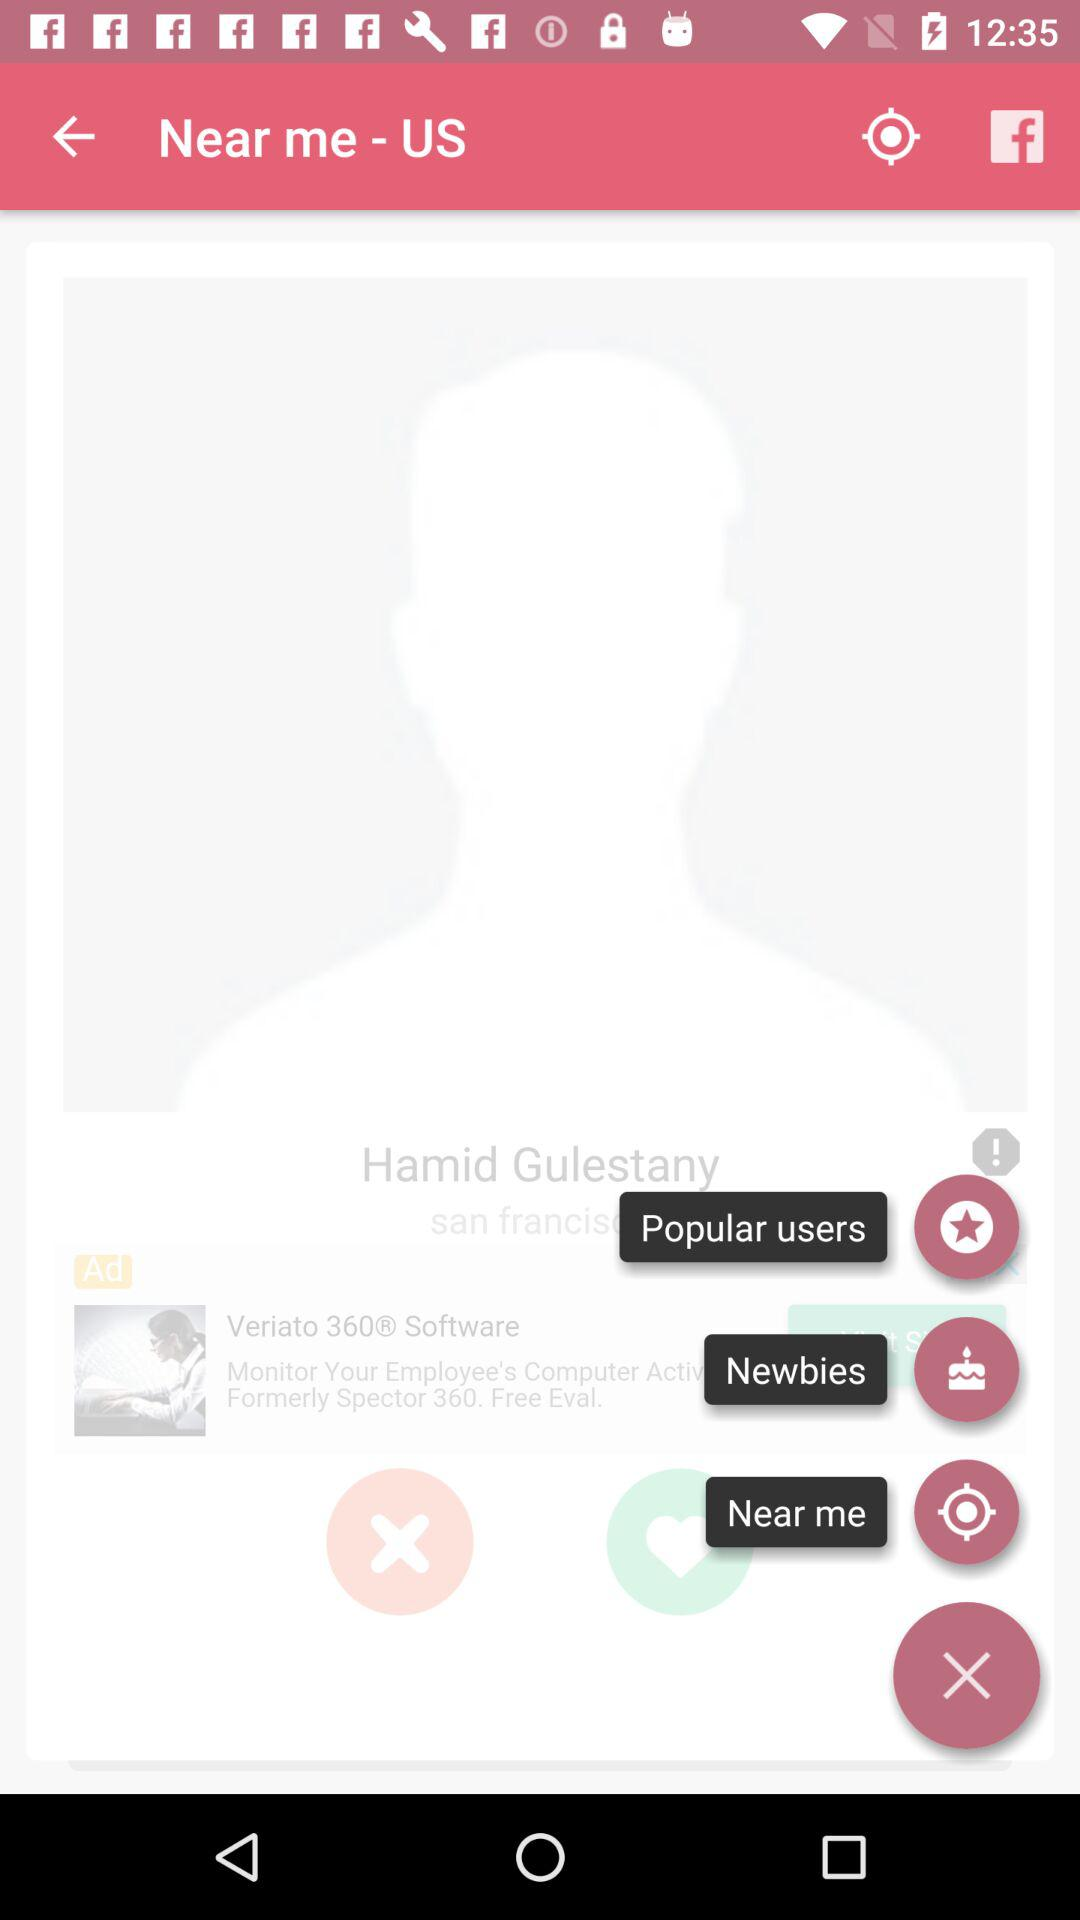What is the location? The location is the United States. 